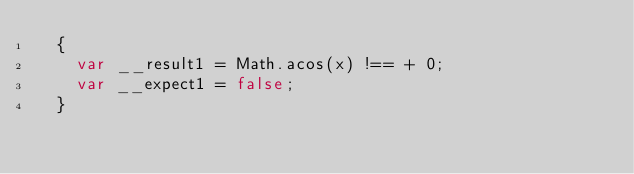Convert code to text. <code><loc_0><loc_0><loc_500><loc_500><_JavaScript_>  {
    var __result1 = Math.acos(x) !== + 0;
    var __expect1 = false;
  }
  </code> 